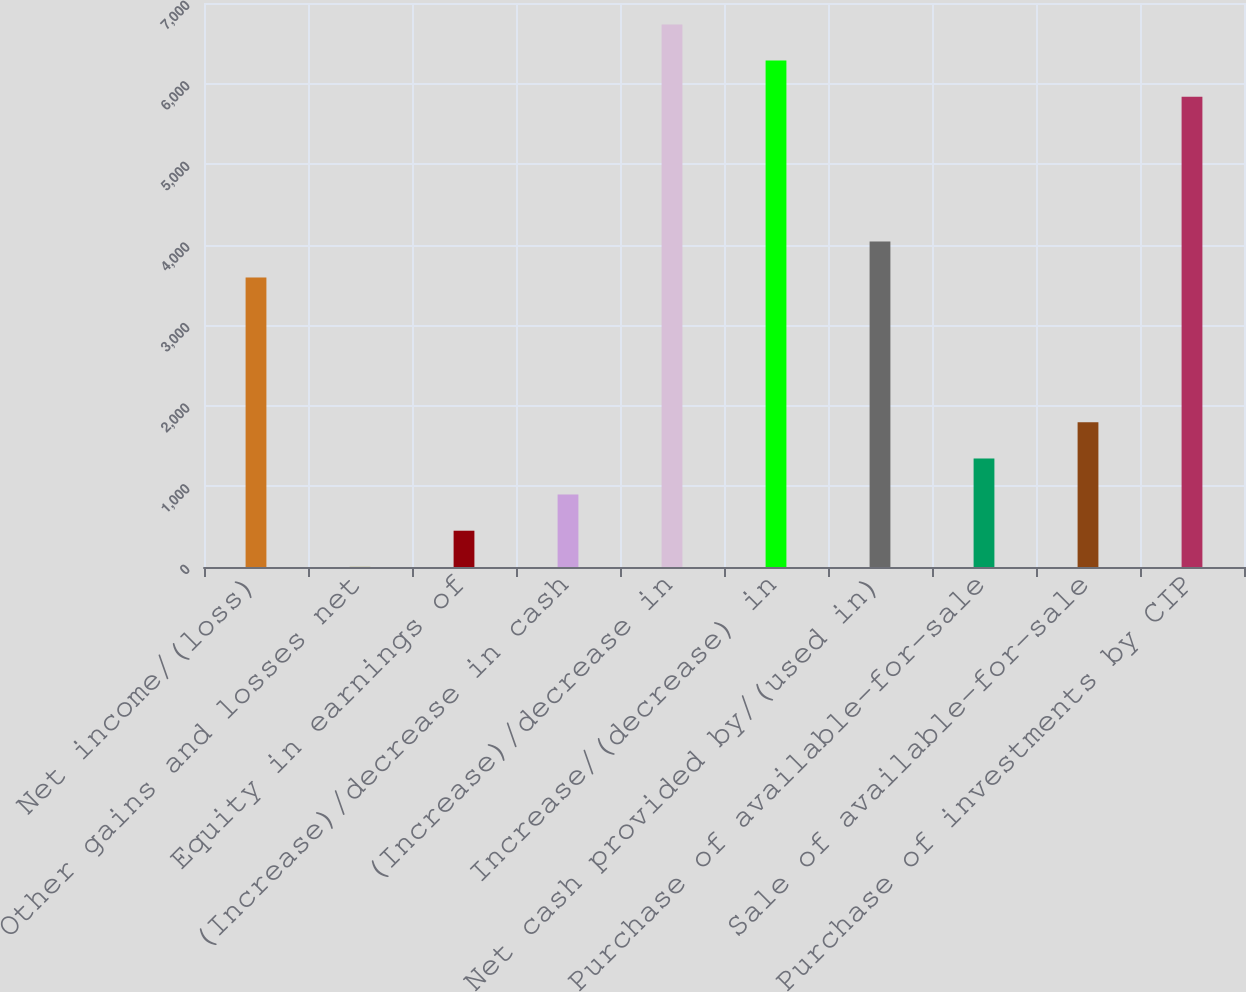Convert chart. <chart><loc_0><loc_0><loc_500><loc_500><bar_chart><fcel>Net income/(loss)<fcel>Other gains and losses net<fcel>Equity in earnings of<fcel>(Increase)/decrease in cash<fcel>(Increase)/decrease in<fcel>Increase/(decrease) in<fcel>Net cash provided by/(used in)<fcel>Purchase of available-for-sale<fcel>Sale of available-for-sale<fcel>Purchase of investments by CIP<nl><fcel>3592.22<fcel>1.5<fcel>450.34<fcel>899.18<fcel>6734.1<fcel>6285.26<fcel>4041.06<fcel>1348.02<fcel>1796.86<fcel>5836.42<nl></chart> 